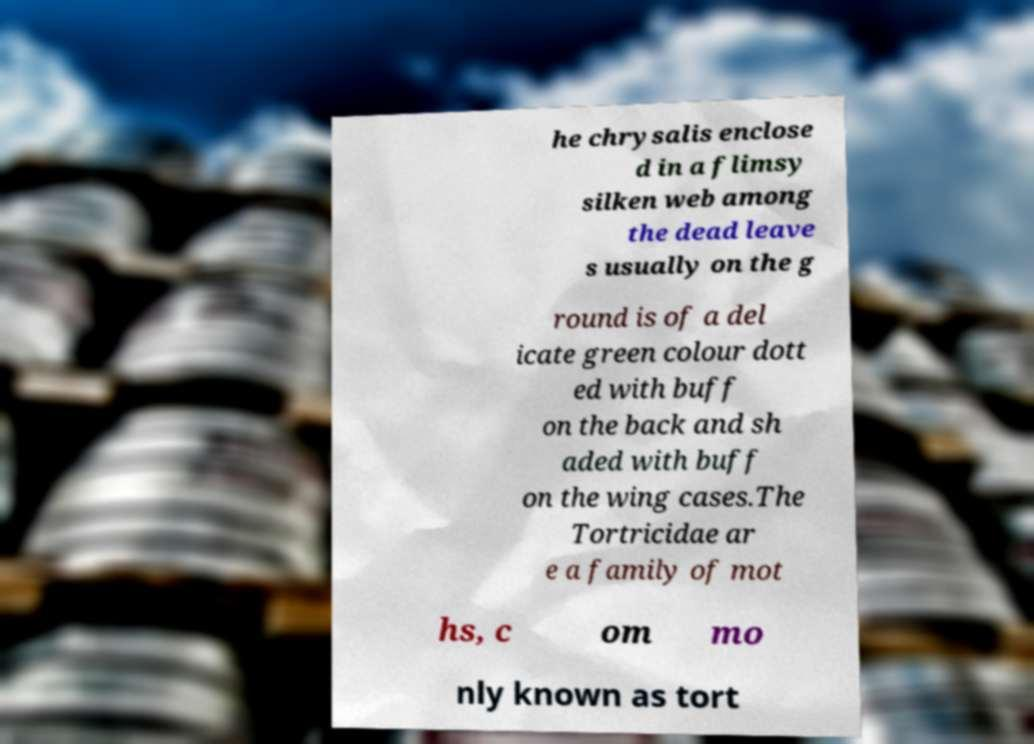Please read and relay the text visible in this image. What does it say? he chrysalis enclose d in a flimsy silken web among the dead leave s usually on the g round is of a del icate green colour dott ed with buff on the back and sh aded with buff on the wing cases.The Tortricidae ar e a family of mot hs, c om mo nly known as tort 